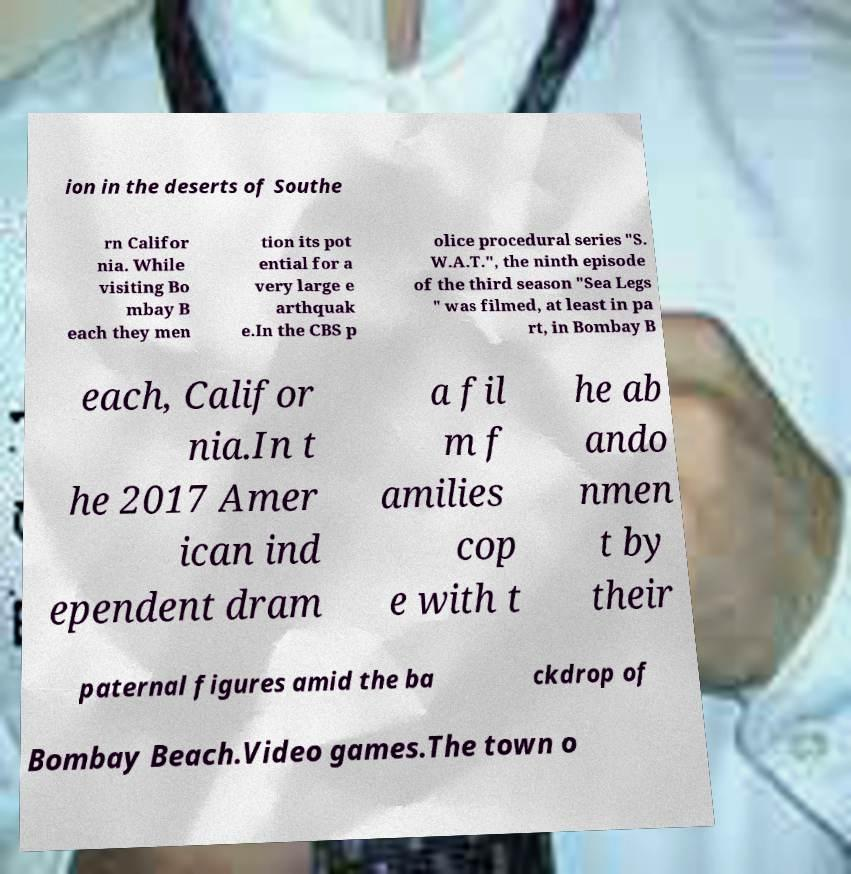Could you assist in decoding the text presented in this image and type it out clearly? ion in the deserts of Southe rn Califor nia. While visiting Bo mbay B each they men tion its pot ential for a very large e arthquak e.In the CBS p olice procedural series "S. W.A.T.", the ninth episode of the third season "Sea Legs " was filmed, at least in pa rt, in Bombay B each, Califor nia.In t he 2017 Amer ican ind ependent dram a fil m f amilies cop e with t he ab ando nmen t by their paternal figures amid the ba ckdrop of Bombay Beach.Video games.The town o 